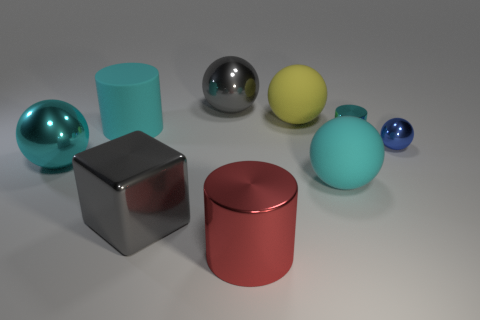How many other things are there of the same color as the small metallic cylinder?
Your answer should be very brief. 3. Is the color of the block the same as the large metal thing that is behind the blue shiny sphere?
Offer a very short reply. Yes. Is there a large gray thing that has the same material as the red thing?
Offer a very short reply. Yes. What number of things are tiny metallic balls or small red matte cylinders?
Your answer should be very brief. 1. Do the big gray block and the big cyan ball on the left side of the red cylinder have the same material?
Keep it short and to the point. Yes. What size is the metal thing that is behind the yellow rubber ball?
Your answer should be very brief. Large. Is the number of large red cylinders less than the number of big rubber objects?
Your response must be concise. Yes. Are there any shiny balls of the same color as the block?
Provide a short and direct response. Yes. What is the shape of the large cyan thing that is left of the red object and in front of the cyan matte cylinder?
Ensure brevity in your answer.  Sphere. What shape is the cyan matte thing on the left side of the big gray shiny object that is behind the large yellow rubber sphere?
Give a very brief answer. Cylinder. 